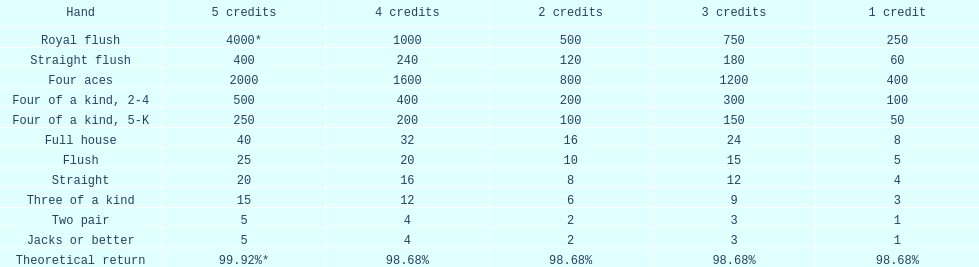Is a 2-point full house equivalent to a 5-point three of a kind? No. Write the full table. {'header': ['Hand', '5 credits', '4 credits', '2 credits', '3 credits', '1 credit'], 'rows': [['Royal flush', '4000*', '1000', '500', '750', '250'], ['Straight flush', '400', '240', '120', '180', '60'], ['Four aces', '2000', '1600', '800', '1200', '400'], ['Four of a kind, 2-4', '500', '400', '200', '300', '100'], ['Four of a kind, 5-K', '250', '200', '100', '150', '50'], ['Full house', '40', '32', '16', '24', '8'], ['Flush', '25', '20', '10', '15', '5'], ['Straight', '20', '16', '8', '12', '4'], ['Three of a kind', '15', '12', '6', '9', '3'], ['Two pair', '5', '4', '2', '3', '1'], ['Jacks or better', '5', '4', '2', '3', '1'], ['Theoretical return', '99.92%*', '98.68%', '98.68%', '98.68%', '98.68%']]} 